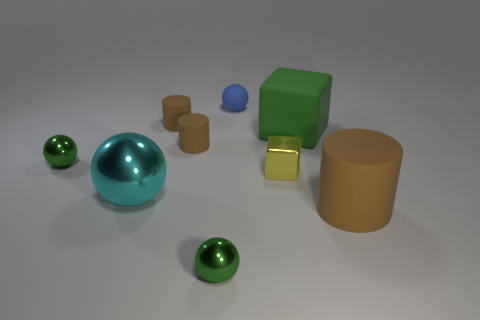Are there fewer tiny gray spheres than tiny green balls?
Provide a succinct answer. Yes. What number of other metal things are the same shape as the big shiny thing?
Your answer should be compact. 2. There is a cylinder that is the same size as the green rubber cube; what is its color?
Your answer should be compact. Brown. Are there the same number of large cylinders that are behind the metal cube and cylinders behind the small blue ball?
Ensure brevity in your answer.  Yes. Are there any brown shiny blocks that have the same size as the blue matte object?
Offer a very short reply. No. What is the size of the yellow metallic cube?
Keep it short and to the point. Small. Is the number of cyan objects that are to the right of the large brown matte cylinder the same as the number of things?
Offer a very short reply. No. How many other things are the same color as the large matte block?
Make the answer very short. 2. What color is the small shiny thing that is both behind the large brown rubber object and on the left side of the small yellow metallic object?
Your answer should be compact. Green. What size is the green sphere that is behind the tiny green metallic ball that is in front of the tiny shiny block left of the large cylinder?
Provide a succinct answer. Small. 